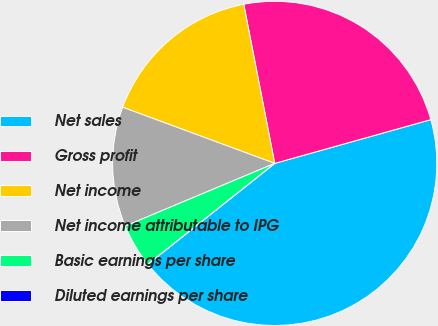Convert chart to OTSL. <chart><loc_0><loc_0><loc_500><loc_500><pie_chart><fcel>Net sales<fcel>Gross profit<fcel>Net income<fcel>Net income attributable to IPG<fcel>Basic earnings per share<fcel>Diluted earnings per share<nl><fcel>43.66%<fcel>23.71%<fcel>16.31%<fcel>11.95%<fcel>4.37%<fcel>0.0%<nl></chart> 